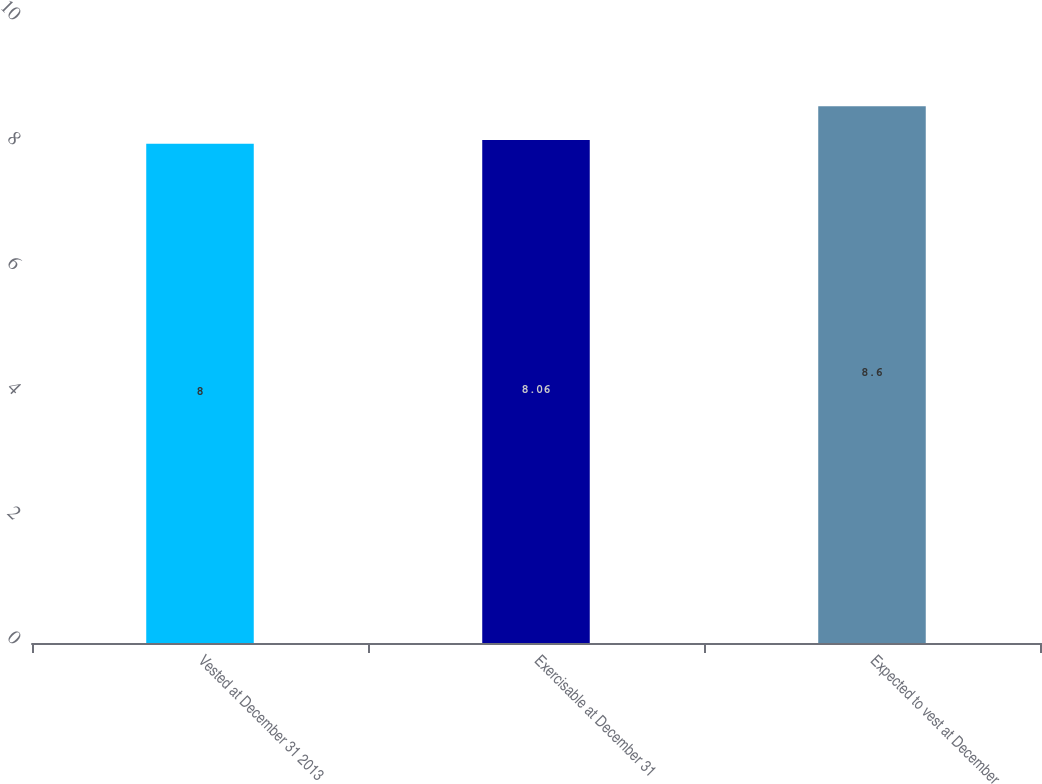<chart> <loc_0><loc_0><loc_500><loc_500><bar_chart><fcel>Vested at December 31 2013<fcel>Exercisable at December 31<fcel>Expected to vest at December<nl><fcel>8<fcel>8.06<fcel>8.6<nl></chart> 